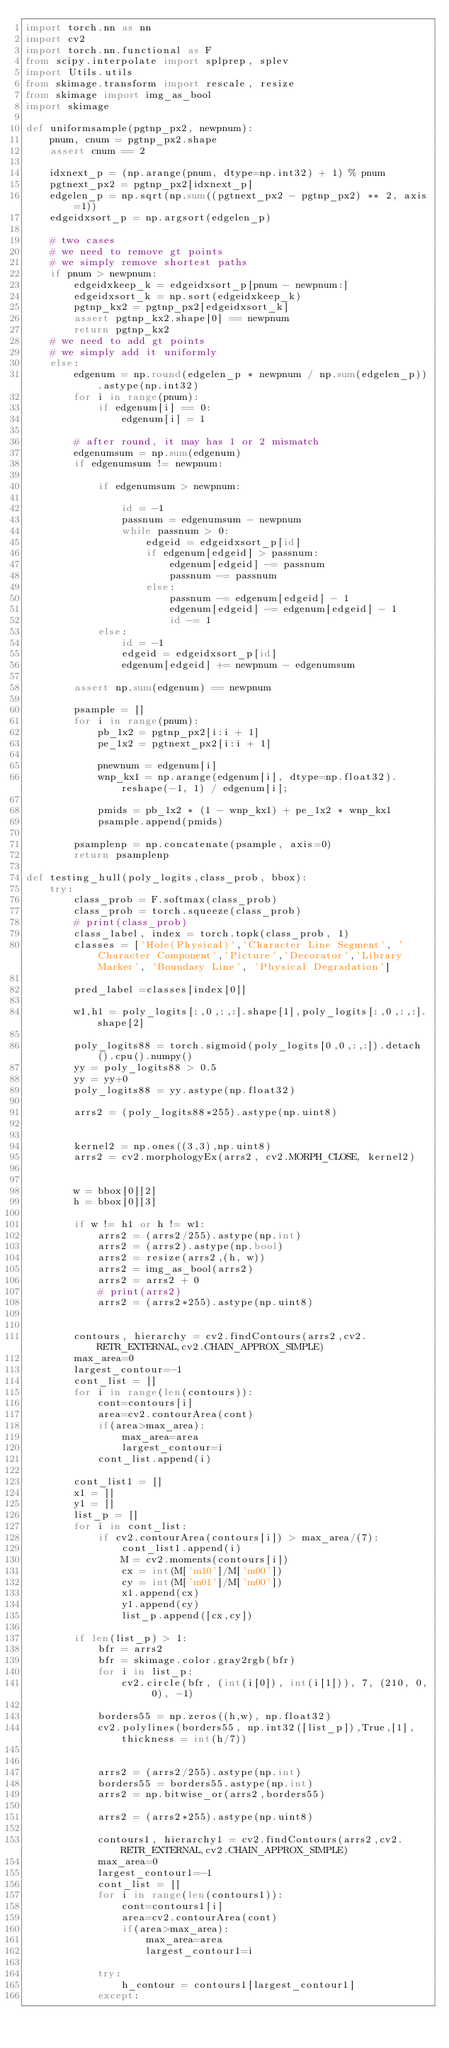Convert code to text. <code><loc_0><loc_0><loc_500><loc_500><_Python_>import torch.nn as nn
import cv2
import torch.nn.functional as F
from scipy.interpolate import splprep, splev
import Utils.utils
from skimage.transform import rescale, resize
from skimage import img_as_bool
import skimage

def uniformsample(pgtnp_px2, newpnum):
    pnum, cnum = pgtnp_px2.shape
    assert cnum == 2

    idxnext_p = (np.arange(pnum, dtype=np.int32) + 1) % pnum
    pgtnext_px2 = pgtnp_px2[idxnext_p]
    edgelen_p = np.sqrt(np.sum((pgtnext_px2 - pgtnp_px2) ** 2, axis=1))
    edgeidxsort_p = np.argsort(edgelen_p)

    # two cases
    # we need to remove gt points
    # we simply remove shortest paths
    if pnum > newpnum:
        edgeidxkeep_k = edgeidxsort_p[pnum - newpnum:]
        edgeidxsort_k = np.sort(edgeidxkeep_k)
        pgtnp_kx2 = pgtnp_px2[edgeidxsort_k]
        assert pgtnp_kx2.shape[0] == newpnum
        return pgtnp_kx2
    # we need to add gt points
    # we simply add it uniformly
    else:
        edgenum = np.round(edgelen_p * newpnum / np.sum(edgelen_p)).astype(np.int32)
        for i in range(pnum):
            if edgenum[i] == 0:
                edgenum[i] = 1

        # after round, it may has 1 or 2 mismatch
        edgenumsum = np.sum(edgenum)
        if edgenumsum != newpnum:

            if edgenumsum > newpnum:

                id = -1
                passnum = edgenumsum - newpnum
                while passnum > 0:
                    edgeid = edgeidxsort_p[id]
                    if edgenum[edgeid] > passnum:
                        edgenum[edgeid] -= passnum
                        passnum -= passnum
                    else:
                        passnum -= edgenum[edgeid] - 1
                        edgenum[edgeid] -= edgenum[edgeid] - 1
                        id -= 1
            else:
                id = -1
                edgeid = edgeidxsort_p[id]
                edgenum[edgeid] += newpnum - edgenumsum

        assert np.sum(edgenum) == newpnum

        psample = []
        for i in range(pnum):
            pb_1x2 = pgtnp_px2[i:i + 1]
            pe_1x2 = pgtnext_px2[i:i + 1]

            pnewnum = edgenum[i]
            wnp_kx1 = np.arange(edgenum[i], dtype=np.float32).reshape(-1, 1) / edgenum[i];

            pmids = pb_1x2 * (1 - wnp_kx1) + pe_1x2 * wnp_kx1
            psample.append(pmids)

        psamplenp = np.concatenate(psample, axis=0)
        return psamplenp

def testing_hull(poly_logits,class_prob, bbox):
    try:
        class_prob = F.softmax(class_prob)
        class_prob = torch.squeeze(class_prob)
        # print(class_prob)
        class_label, index = torch.topk(class_prob, 1)
        classes = ['Hole(Physical)','Character Line Segment', 'Character Component','Picture','Decorator','Library Marker', 'Boundary Line', 'Physical Degradation']
        
        pred_label =classes[index[0]]

        w1,h1 = poly_logits[:,0,:,:].shape[1],poly_logits[:,0,:,:].shape[2]

        poly_logits88 = torch.sigmoid(poly_logits[0,0,:,:]).detach().cpu().numpy()
        yy = poly_logits88 > 0.5
        yy = yy+0
        poly_logits88 = yy.astype(np.float32)

        arrs2 = (poly_logits88*255).astype(np.uint8)

        
        kernel2 = np.ones((3,3),np.uint8)
        arrs2 = cv2.morphologyEx(arrs2, cv2.MORPH_CLOSE, kernel2)


        w = bbox[0][2]
        h = bbox[0][3]

        if w != h1 or h != w1:
            arrs2 = (arrs2/255).astype(np.int)
            arrs2 = (arrs2).astype(np.bool)
            arrs2 = resize(arrs2,(h, w))
            arrs2 = img_as_bool(arrs2)
            arrs2 = arrs2 + 0
            # print(arrs2)
            arrs2 = (arrs2*255).astype(np.uint8)


        contours, hierarchy = cv2.findContours(arrs2,cv2.RETR_EXTERNAL,cv2.CHAIN_APPROX_SIMPLE)
        max_area=0
        largest_contour=-1
        cont_list = []
        for i in range(len(contours)):
            cont=contours[i]
            area=cv2.contourArea(cont)
            if(area>max_area):
                max_area=area
                largest_contour=i
            cont_list.append(i)
        
        cont_list1 = []
        x1 = []
        y1 = []
        list_p = []
        for i in cont_list:
            if cv2.contourArea(contours[i]) > max_area/(7):
                cont_list1.append(i)
                M = cv2.moments(contours[i])
                cx = int(M['m10']/M['m00'])
                cy = int(M['m01']/M['m00'])
                x1.append(cx)
                y1.append(cy)
                list_p.append([cx,cy])

        if len(list_p) > 1:
            bfr = arrs2
            bfr = skimage.color.gray2rgb(bfr)
            for i in list_p:
                cv2.circle(bfr, (int(i[0]), int(i[1])), 7, (210, 0, 0), -1)

            borders55 = np.zeros((h,w), np.float32)
            cv2.polylines(borders55, np.int32([list_p]),True,[1], thickness = int(h/7))


            arrs2 = (arrs2/255).astype(np.int)
            borders55 = borders55.astype(np.int)
            arrs2 = np.bitwise_or(arrs2,borders55)

            arrs2 = (arrs2*255).astype(np.uint8)

            contours1, hierarchy1 = cv2.findContours(arrs2,cv2.RETR_EXTERNAL,cv2.CHAIN_APPROX_SIMPLE)
            max_area=0
            largest_contour1=-1
            cont_list = []
            for i in range(len(contours1)):
                cont=contours1[i]
                area=cv2.contourArea(cont)
                if(area>max_area):
                    max_area=area
                    largest_contour1=i

            try:
                h_contour = contours1[largest_contour1]
            except:</code> 